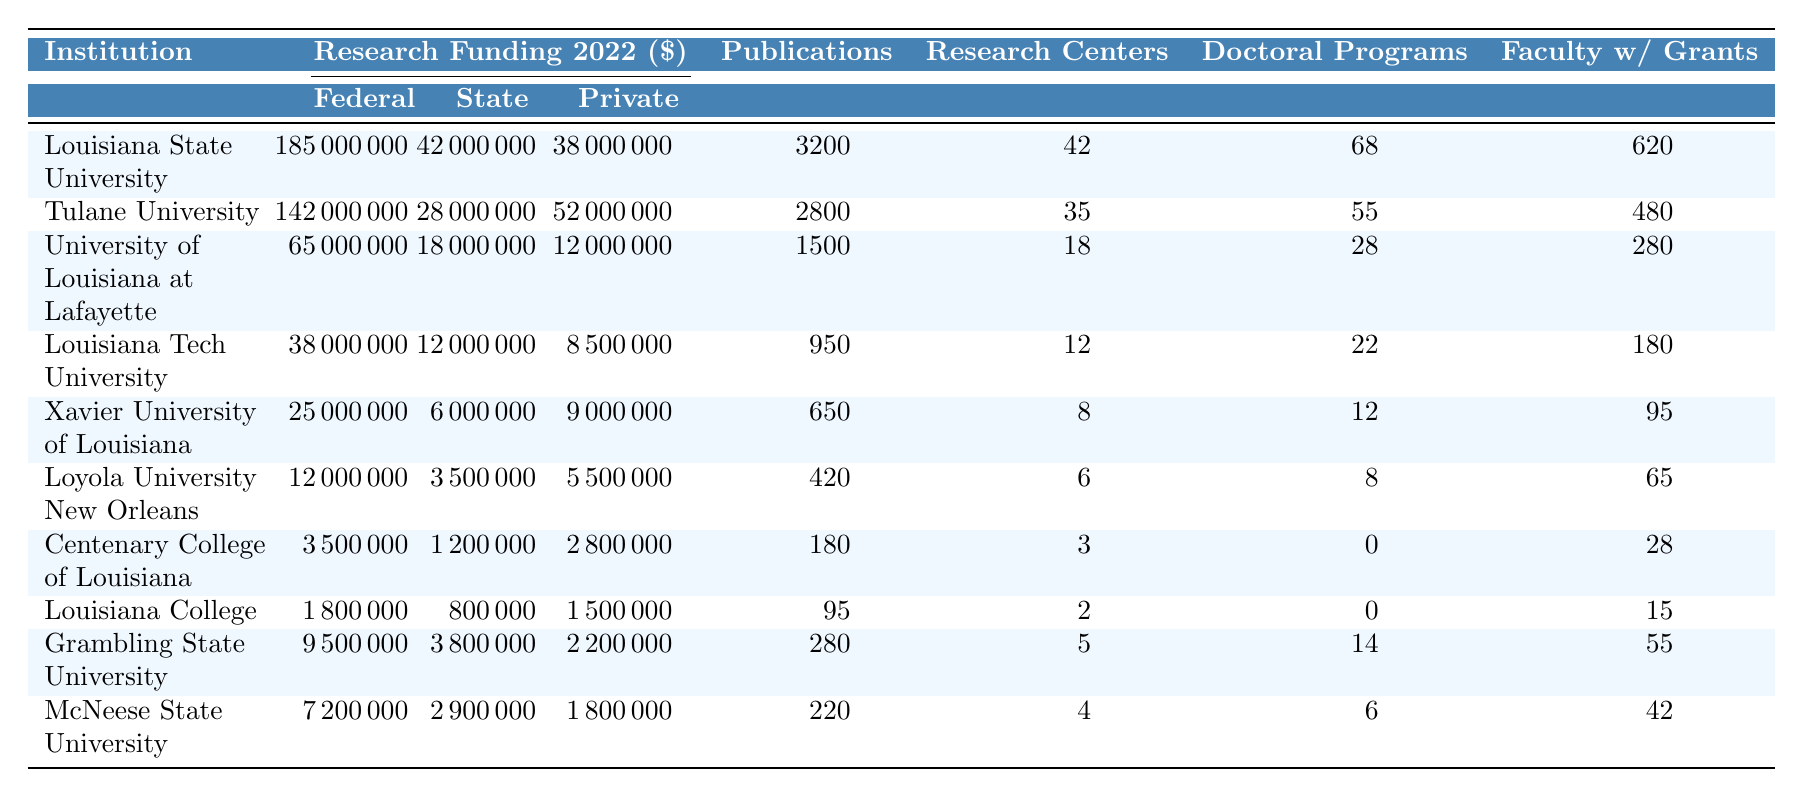What institution received the highest federal research funding in 2022? Louisiana State University received the highest federal research funding of $185,000,000 in 2022, as per the value in the table under the Federal Research Funding 2022 column.
Answer: Louisiana State University What is the total amount of state research funding received by all institutions combined in 2022? To find the total state research funding, sum the values in the State Research Funding 2022 column: 42000000 + 28000000 + 18000000 + 12000000 + 6000000 + 3500000 + 1200000 + 800000 + 3800000 + 2900000 =  108000000.
Answer: 108000000 Which institution has more doctoral programs offered, Louisiana College or Xavier University of Louisiana? Louisiana College and Xavier University of Louisiana offer 0 and 12 doctoral programs respectively. Since 12 is greater than 0, Xavier University offers more doctoral programs.
Answer: Xavier University of Louisiana What percentage of total research publications in 2022 were attributed to Louisiana State University? The total publications across all institutions is 3200 + 2800 + 1500 + 950 + 650 + 420 + 180 + 95 + 280 + 220 = 11890. Louisiana State University had 3200 publications, which is (3200 / 11890) * 100 ≈ 26.92%.
Answer: Approximately 26.92% How many institutions have federal research funding above $50 million in 2022? Looking at the Federal Research Funding 2022 column, Louisiana State University, Tulane University, and University of Louisiana at Lafayette all have federal funding above $50 million, totaling 3 institutions.
Answer: 3 What is the difference in total research funding between Tulane University and Louisiana College in 2022? For Tulane University, total funding equals federal ($142,000,000) + state ($28,000,000) + private ($52,000,000) = $222,000,000. For Louisiana College, it is federal ($1,800,000) + state ($800,000) + private ($1,500,000) = $4,100,000. The difference is $222,000,000 - $4,100,000 = $217,900,000.
Answer: $217,900,000 Is it true that McNeese State University has more faculty with active grants than Loyola University New Orleans? According to the table, McNeese State University has 42 faculty with active grants while Loyola University New Orleans has 65. Since 42 is less than 65, it is not true.
Answer: No Which institution has the least number of research centers and how many do they have? Centenary College of Louisiana has the least number of research centers, with the count being 3, as noted in the Research Centers Count column.
Answer: Centenary College of Louisiana, 3 Which institution has the highest private research funding amount in 2022? Tulane University received the highest private research funding amount of $52,000,000, as shown under the Private Research Funding 2022 column.
Answer: Tulane University How many more research publications did Louisiana State University have compared to Grambling State University in 2022? Louisiana State University had 3200 publications and Grambling State University had 280 publications. The difference is 3200 - 280 = 2920 publications.
Answer: 2920 How many institutions have more than 10 research centers? The institutions with more than 10 research centers are Louisiana State University (42), Tulane University (35), and University of Louisiana at Lafayette (18). Therefore, there are 3 such institutions.
Answer: 3 